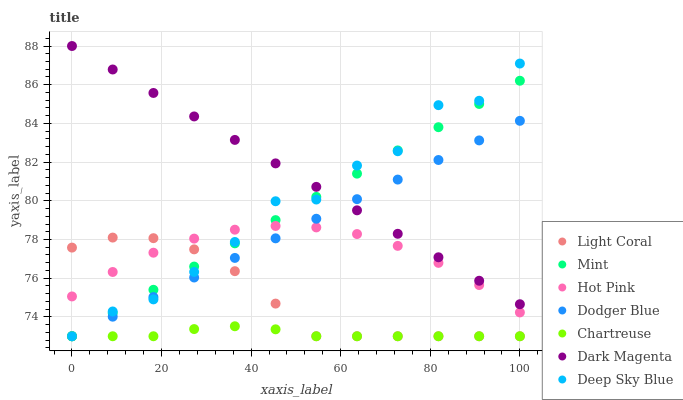Does Chartreuse have the minimum area under the curve?
Answer yes or no. Yes. Does Dark Magenta have the maximum area under the curve?
Answer yes or no. Yes. Does Hot Pink have the minimum area under the curve?
Answer yes or no. No. Does Hot Pink have the maximum area under the curve?
Answer yes or no. No. Is Dark Magenta the smoothest?
Answer yes or no. Yes. Is Deep Sky Blue the roughest?
Answer yes or no. Yes. Is Hot Pink the smoothest?
Answer yes or no. No. Is Hot Pink the roughest?
Answer yes or no. No. Does Light Coral have the lowest value?
Answer yes or no. Yes. Does Hot Pink have the lowest value?
Answer yes or no. No. Does Dark Magenta have the highest value?
Answer yes or no. Yes. Does Hot Pink have the highest value?
Answer yes or no. No. Is Chartreuse less than Hot Pink?
Answer yes or no. Yes. Is Dark Magenta greater than Chartreuse?
Answer yes or no. Yes. Does Chartreuse intersect Dodger Blue?
Answer yes or no. Yes. Is Chartreuse less than Dodger Blue?
Answer yes or no. No. Is Chartreuse greater than Dodger Blue?
Answer yes or no. No. Does Chartreuse intersect Hot Pink?
Answer yes or no. No. 